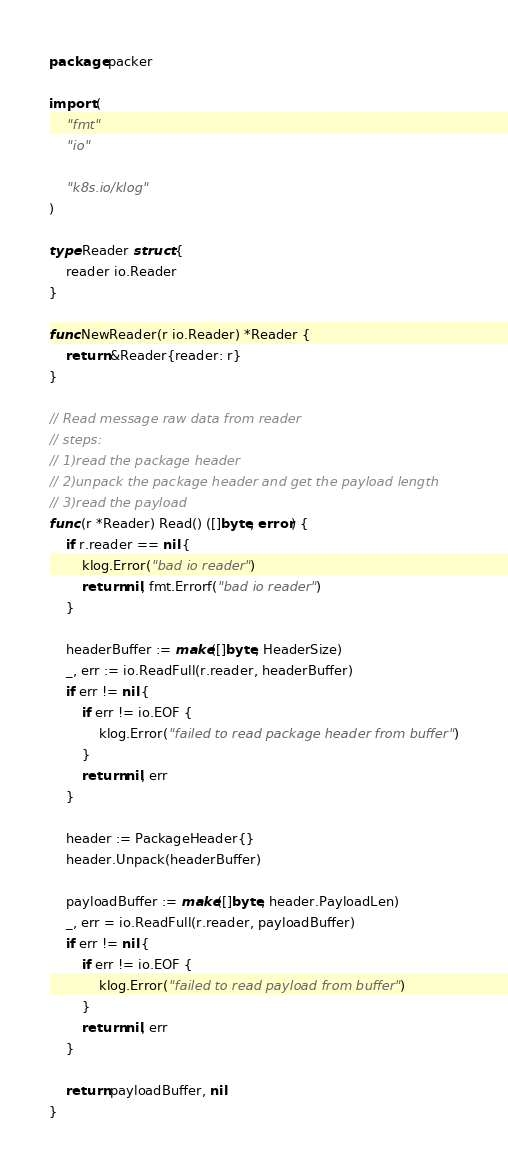<code> <loc_0><loc_0><loc_500><loc_500><_Go_>package packer

import (
	"fmt"
	"io"

	"k8s.io/klog"
)

type Reader struct {
	reader io.Reader
}

func NewReader(r io.Reader) *Reader {
	return &Reader{reader: r}
}

// Read message raw data from reader
// steps:
// 1)read the package header
// 2)unpack the package header and get the payload length
// 3)read the payload
func (r *Reader) Read() ([]byte, error) {
	if r.reader == nil {
		klog.Error("bad io reader")
		return nil, fmt.Errorf("bad io reader")
	}

	headerBuffer := make([]byte, HeaderSize)
	_, err := io.ReadFull(r.reader, headerBuffer)
	if err != nil {
		if err != io.EOF {
			klog.Error("failed to read package header from buffer")
		}
		return nil, err
	}

	header := PackageHeader{}
	header.Unpack(headerBuffer)

	payloadBuffer := make([]byte, header.PayloadLen)
	_, err = io.ReadFull(r.reader, payloadBuffer)
	if err != nil {
		if err != io.EOF {
			klog.Error("failed to read payload from buffer")
		}
		return nil, err
	}

	return payloadBuffer, nil
}
</code> 